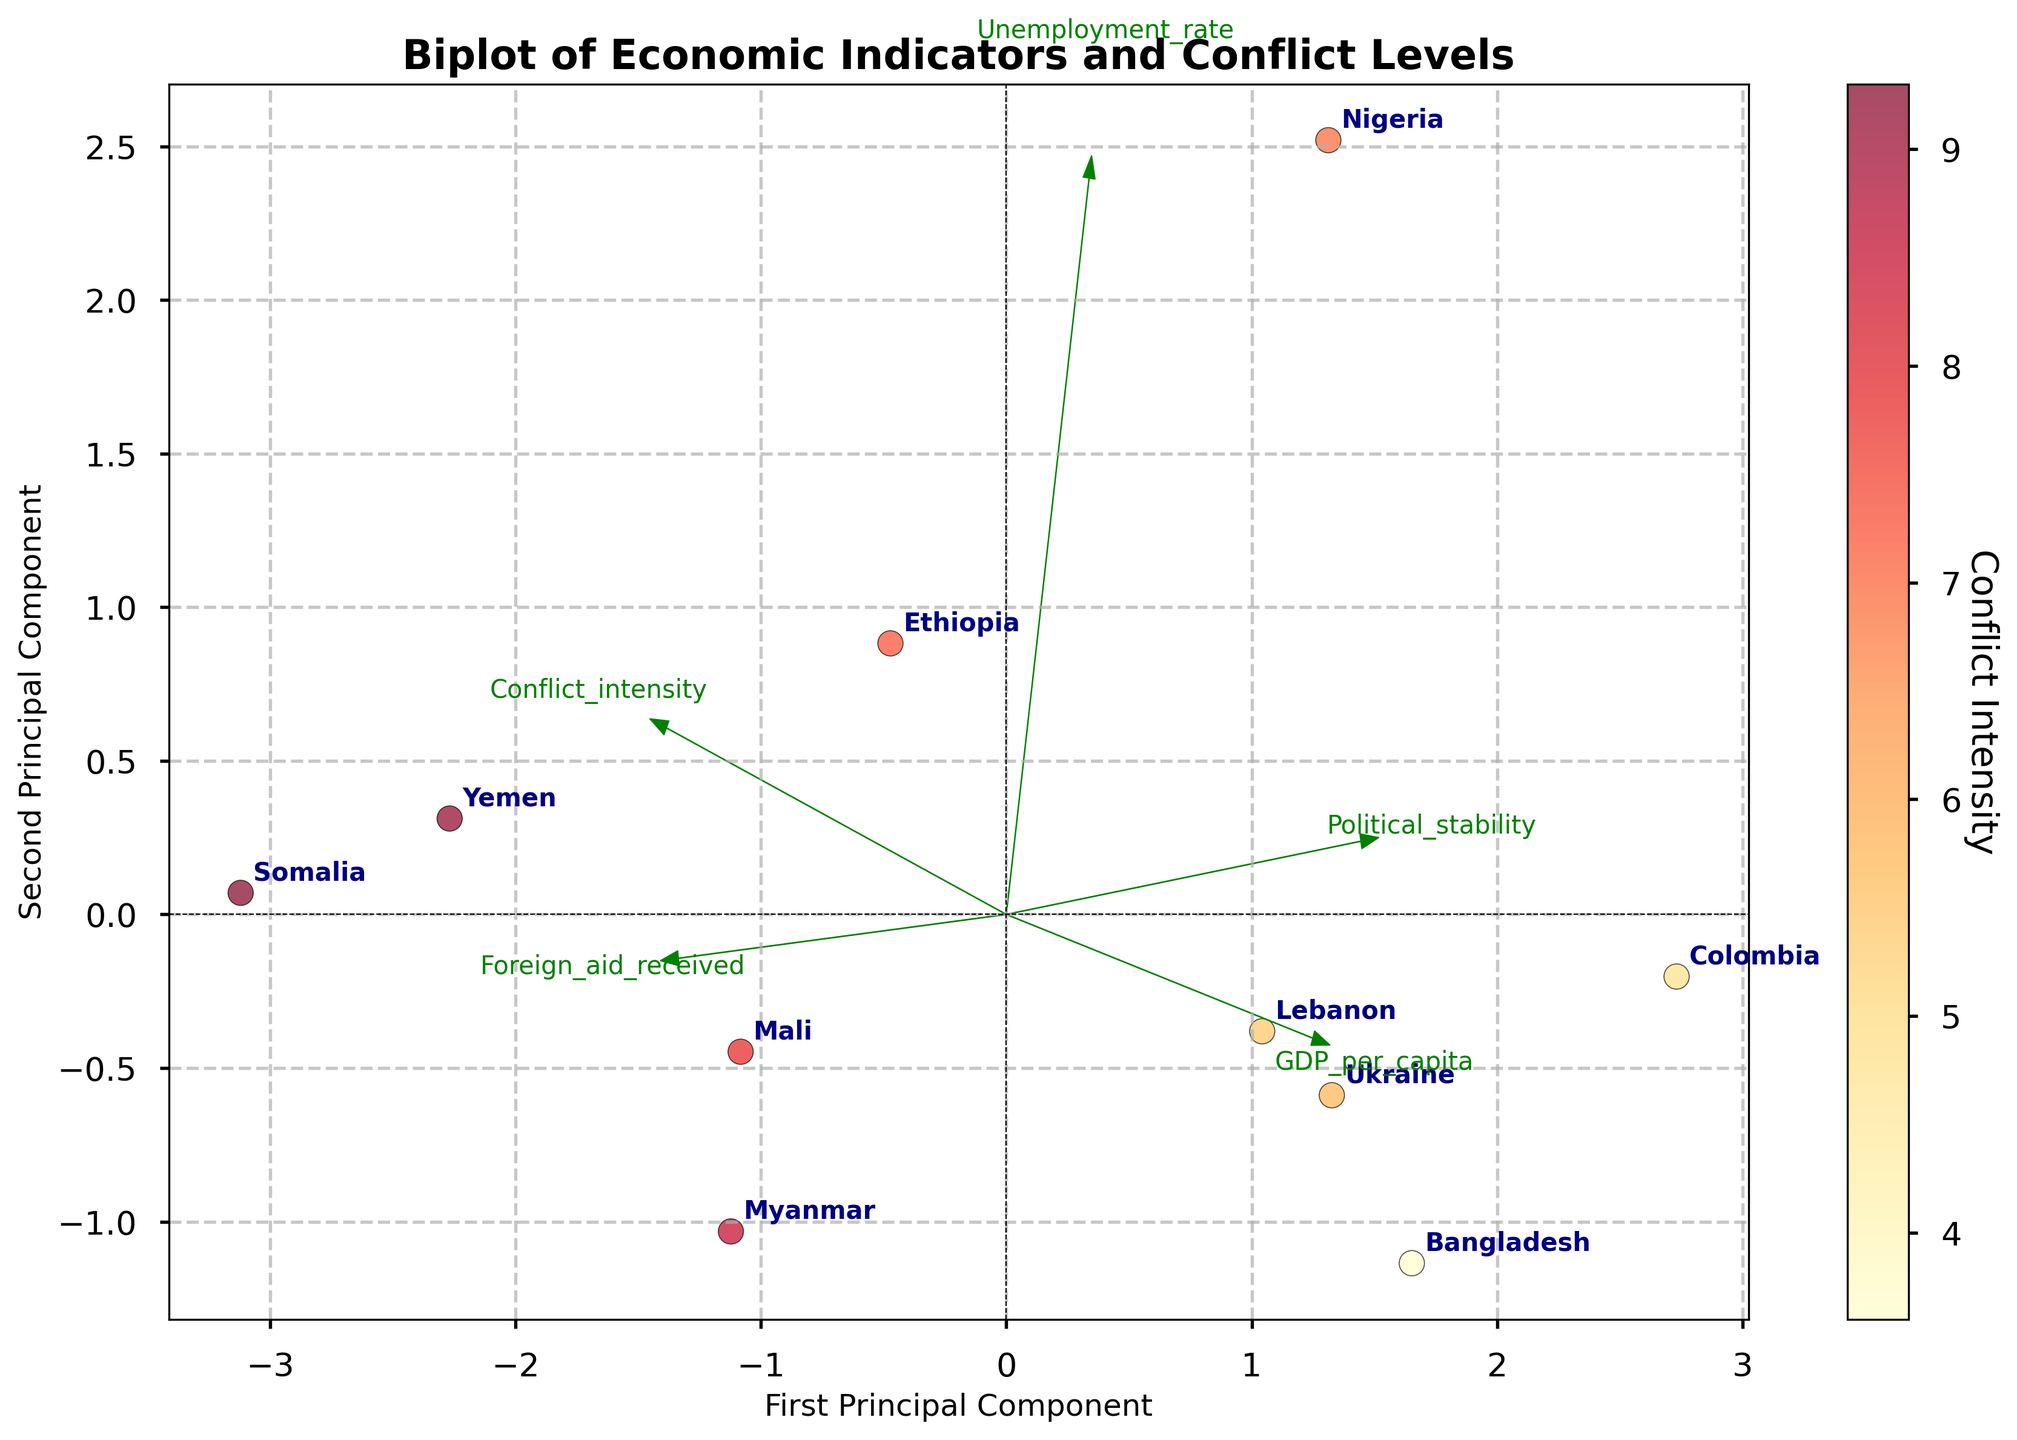What countries are included in the figure? The country names are labels on the scatter plot, each corresponding to a data point. The countries included are: Ethiopia, Colombia, Myanmar, Nigeria, Yemen, Ukraine, Mali, Lebanon, Somalia, and Bangladesh.
Answer: Ethiopia, Colombia, Myanmar, Nigeria, Yemen, Ukraine, Mali, Lebanon, Somalia, Bangladesh What is the title of the figure? The title is displayed at the top of the plot. The title of the figure is "Biplot of Economic Indicators and Conflict Levels."
Answer: Biplot of Economic Indicators and Conflict Levels How many principal components are shown on the axes? The labels and annotations of the axes indicate that two principal components are shown, with the x-axis representing the First Principal Component and the y-axis representing the Second Principal Component.
Answer: Two Which country has the highest conflict intensity based on the color gradient? The scatter plot uses a color gradient (YlOrRd) where darker colors represent higher conflict intensity. Somalia, represented by the darkest color, has the highest conflict intensity.
Answer: Somalia What does the color bar represent? The color bar on the right side of the plot indicates 'Conflict Intensity,' with a gradient that helps identify the intensity levels across different countries.
Answer: Conflict Intensity Which country has the lowest GDP per capita based on its position relative to the GDP per capita vector? The direction of the GDP per capita vector points away from the origin toward countries with higher GDP per capita. Somalia, positioned closest to the origin and opposite the vector's direction, has the lowest GDP per capita.
Answer: Somalia What is the relationship between GDP per capita and Conflict Intensity in the figure? By observing the directions of the vectors for GDP per capita and Conflict intensity, which appear to point in nearly opposite directions, it suggests a negative relationship: as GDP per capita increases, conflict intensity tends to decrease.
Answer: Negative relationship Which country shows high values for both Foreign Aid Received and Conflict Intensity? The vectors for Foreign Aid Received and Conflict Intensity can help identify this country. Somalia, placed in the same direction as both vectors, indicates high values for both variables.
Answer: Somalia Which variable has the smallest influence on the first principal component? The length and direction of each variable's vector relative to the first principal component axis determine its influence. 'Unemployment Rate' has the shortest projection length on the first principal component, indicating the smallest influence.
Answer: Unemployment Rate How do Political Stability and GDP per capita relate to each other according to the plot? The vectors for Political Stability and GDP per capita generally point in the same direction, suggesting a positive relationship: as GDP per capita increases, Political Stability tends to increase as well.
Answer: Positive relationship 